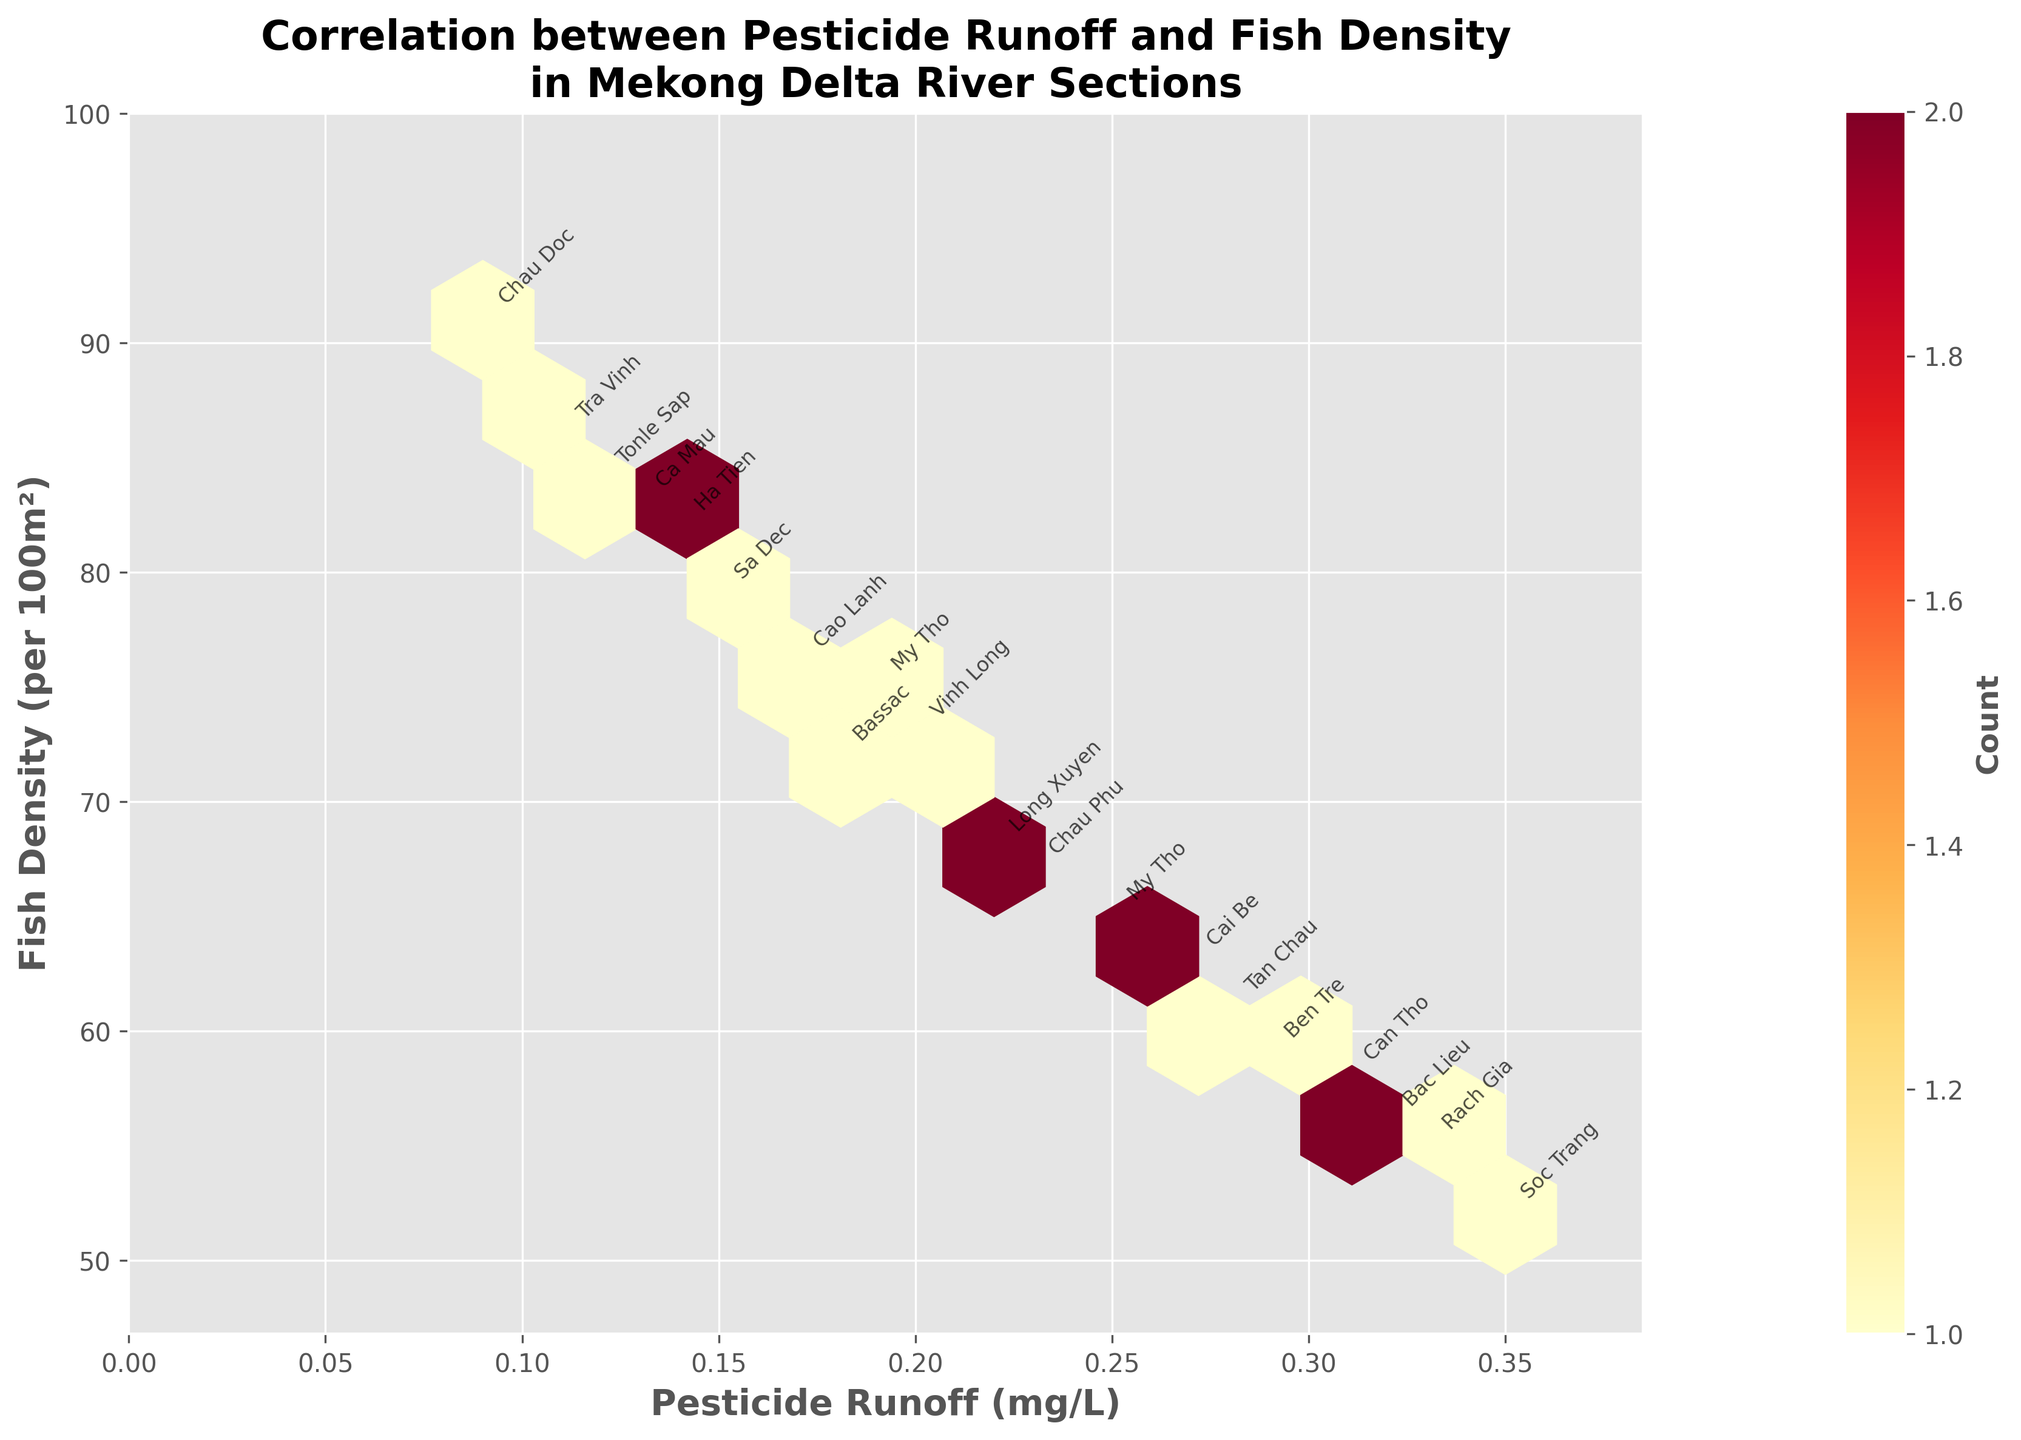What is the title of the plot? The title is usually located at the top of the plot and summarizes the data being visualized. In this case, it should reflect the correlation between pesticide runoff and fish density in different river sections.
Answer: Correlation between Pesticide Runoff and Fish Density in Mekong Delta River Sections What variable is represented on the x-axis? The x-axis label indicates the variable that is plotted horizontally. Checking the plot, we see this representation.
Answer: Pesticide Runoff (mg/L) What variable is represented on the y-axis? The y-axis label indicates the variable that is plotted vertically. Checking the plot, we see this representation.
Answer: Fish Density (per 100m²) Which river section has the highest fish density? By looking at the annotated points on the plot, we can identify the river section that corresponds to the highest value on the y-axis.
Answer: Chau Doc Which river section has the highest pesticide runoff level? By examining the annotated points on the plot, we can identify the river section that corresponds to the highest value on the x-axis.
Answer: Soc Trang Is there an overall trend between pesticide runoff and fish density? By observing the distribution of the hexagons and the general direction they form, we can infer the trend. If hexagons move from high density to low density with increasing pesticide levels, there is an inverse correlation.
Answer: Yes, an inverse correlation What is the general shape of the hexbin visualization? The general shape can be derived by looking at the pattern formed by the hexagons, giving an insight into the correlation between the variables.
Answer: Inverse linear gradient Count the number of hexagons with the highest color intensity. The color intensity represents the number of data points within the hexagon. By counting the hexagons with the maximum color shade, we can answer this question.
Answer: 1 